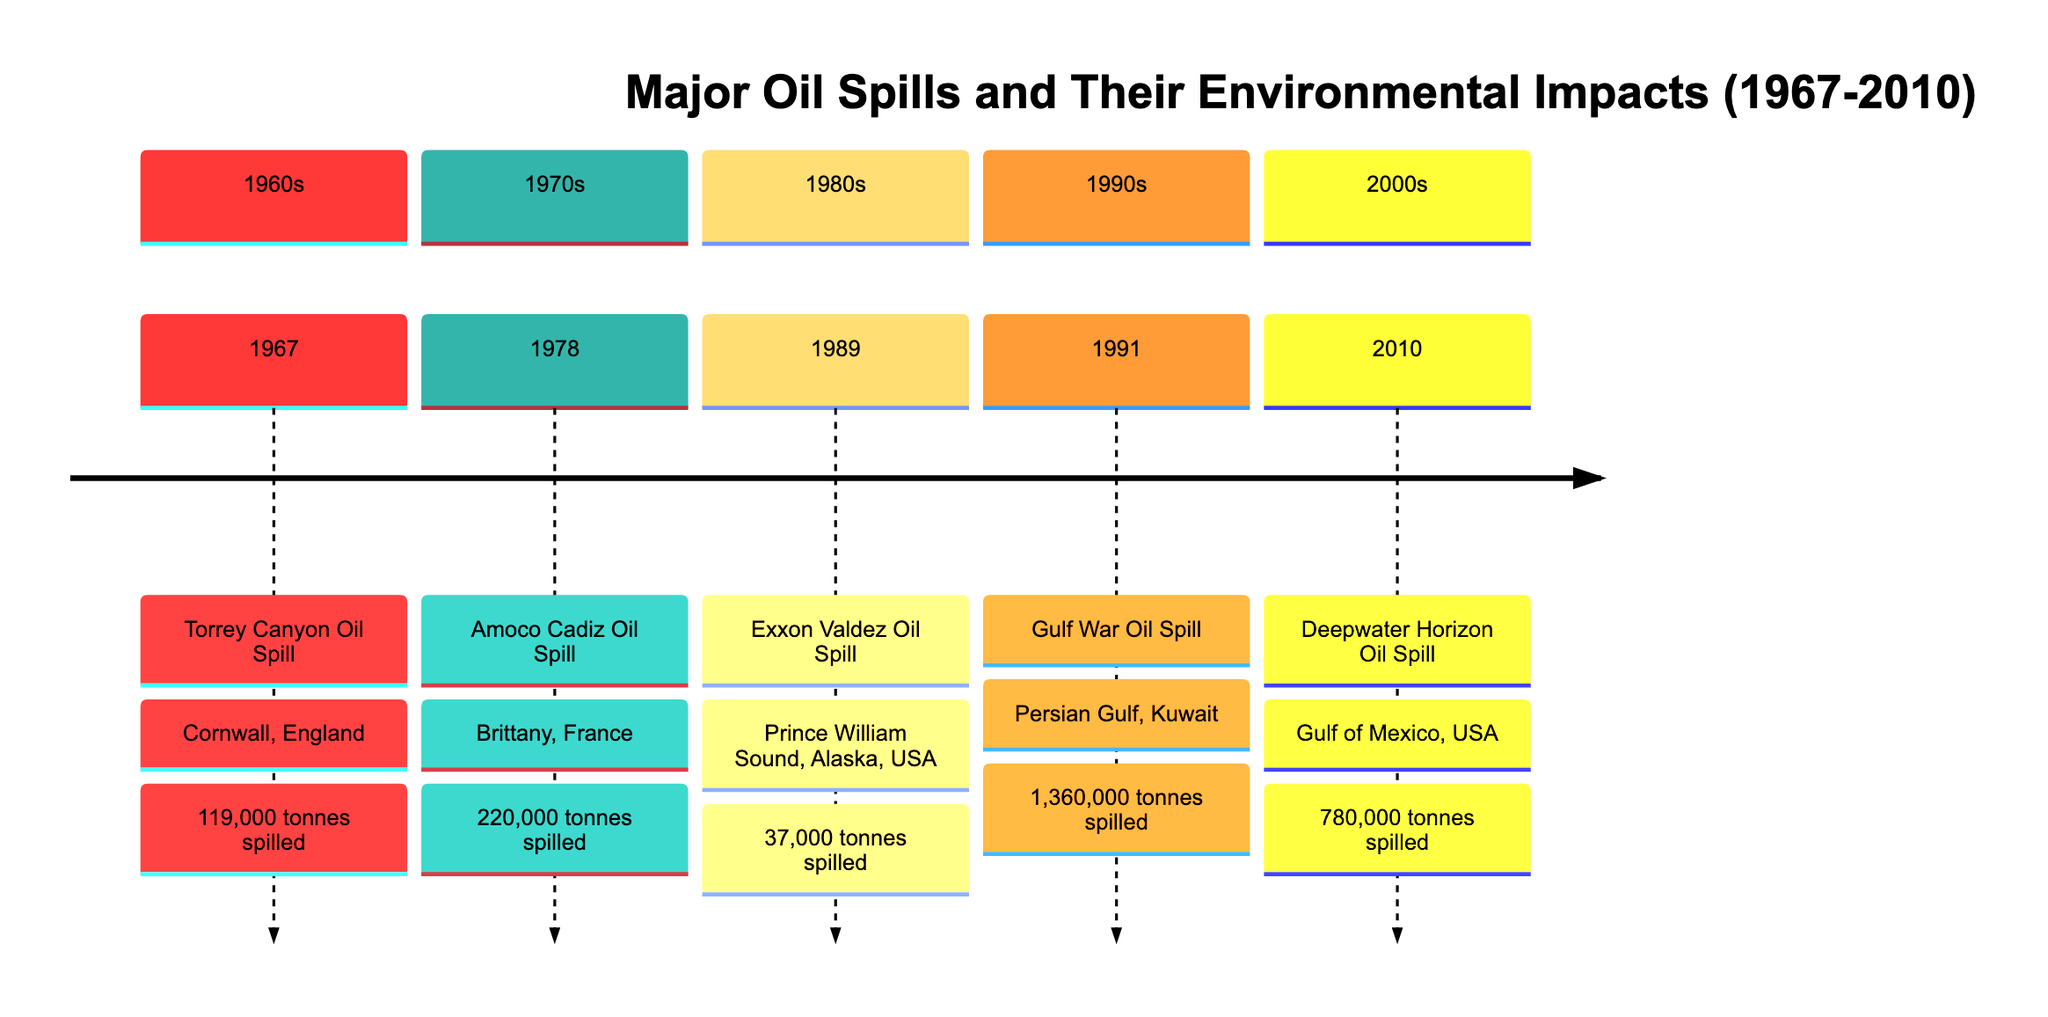What year did the Torrey Canyon oil spill occur? The timeline indicates that the Torrey Canyon oil spill occurred in the year 1967. This is noted at the beginning of the timeline in the section labeled 1960s.
Answer: 1967 How much oil was spilled in the Amoco Cadiz incident? According to the timeline, the Amoco Cadiz oil spill released 220,000 tonnes of crude oil. This detail is found in the 1970s section under the Amoco Cadiz Oil Spill.
Answer: 220,000 tonnes Which incident released the largest amount of oil? By analyzing the amounts spilled in the timeline, the Gulf War Oil Spill in 1991 released the largest quantity at 1,360,000 tonnes. This can be seen in the 1990s section of the diagram.
Answer: 1,360,000 tonnes In which country did the Exxon Valdez oil spill occur? The timeline provides information that the Exxon Valdez oil spill took place in Prince William Sound, Alaska, USA. This is indicated next to the Exxon Valdez spill in the 1980s section.
Answer: Alaska, USA What was the total amount of oil spilled in the 2000s? The timeline shows that during the 2000s, the Deepwater Horizon oil spill released approximately 780,000 tonnes of oil. Thus, the total for that decade is the same since it's the only incident listed.
Answer: 780,000 tonnes Which oil spill occurred first, Torrey Canyon or Amoco Cadiz? By comparing the years in the timeline, the Torrey Canyon oil spill occurred in 1967, while the Amoco Cadiz spill happened in 1978. Therefore, Torrey Canyon happened first.
Answer: Torrey Canyon What is the primary environmental impact mentioned for the Exxon Valdez spill? The timeline states that the Exxon Valdez spill led to long-term environmental impacts, including the deaths of thousands of marine mammals and seabirds. This detail is provided under the Exxon Valdez oil spill description.
Answer: Death of marine mammals and seabirds In what section does the Gulf War Oil Spill appear? The Gulf War Oil Spill is found in the timeline under the 1990s section, where the specific details about the occurrence are presented.
Answer: 1990s What was the location of the Deepwater Horizon oil spill? The timeline specifies that the Deepwater Horizon oil spill occurred in the Gulf of Mexico, USA. This information can be found in the 2000s section of the diagram.
Answer: Gulf of Mexico, USA 